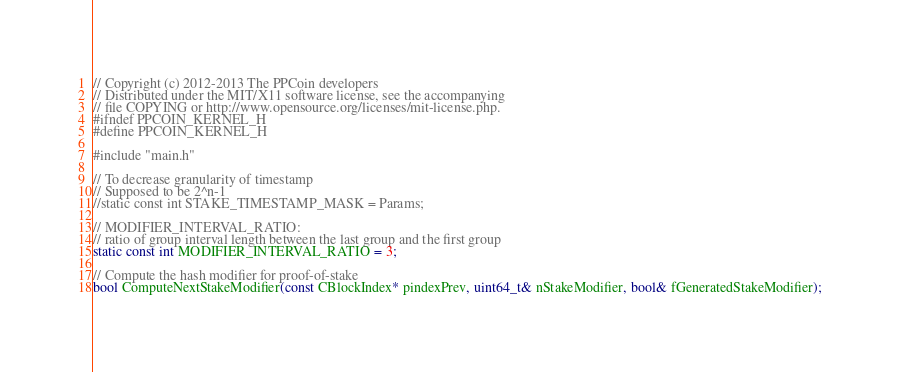Convert code to text. <code><loc_0><loc_0><loc_500><loc_500><_C_>// Copyright (c) 2012-2013 The PPCoin developers
// Distributed under the MIT/X11 software license, see the accompanying
// file COPYING or http://www.opensource.org/licenses/mit-license.php.
#ifndef PPCOIN_KERNEL_H
#define PPCOIN_KERNEL_H

#include "main.h"

// To decrease granularity of timestamp
// Supposed to be 2^n-1
//static const int STAKE_TIMESTAMP_MASK = Params;

// MODIFIER_INTERVAL_RATIO:
// ratio of group interval length between the last group and the first group
static const int MODIFIER_INTERVAL_RATIO = 3;

// Compute the hash modifier for proof-of-stake
bool ComputeNextStakeModifier(const CBlockIndex* pindexPrev, uint64_t& nStakeModifier, bool& fGeneratedStakeModifier);</code> 